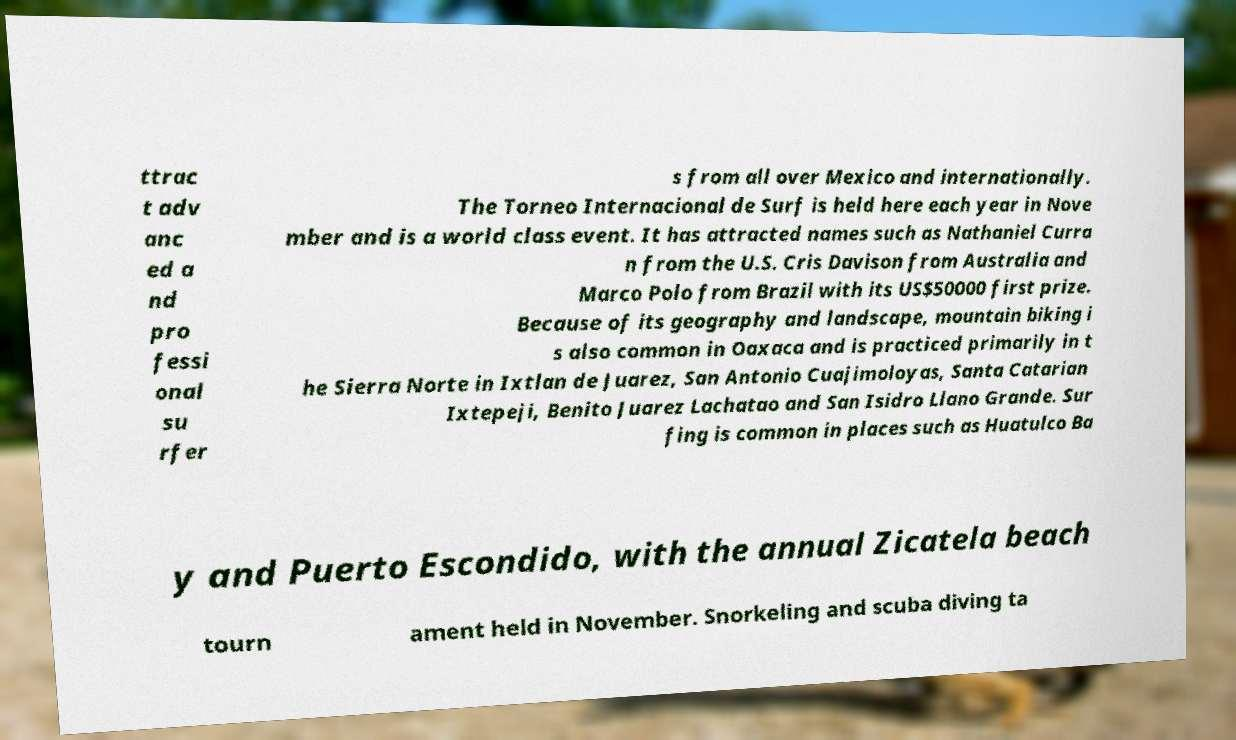Please read and relay the text visible in this image. What does it say? ttrac t adv anc ed a nd pro fessi onal su rfer s from all over Mexico and internationally. The Torneo Internacional de Surf is held here each year in Nove mber and is a world class event. It has attracted names such as Nathaniel Curra n from the U.S. Cris Davison from Australia and Marco Polo from Brazil with its US$50000 first prize. Because of its geography and landscape, mountain biking i s also common in Oaxaca and is practiced primarily in t he Sierra Norte in Ixtlan de Juarez, San Antonio Cuajimoloyas, Santa Catarian Ixtepeji, Benito Juarez Lachatao and San Isidro Llano Grande. Sur fing is common in places such as Huatulco Ba y and Puerto Escondido, with the annual Zicatela beach tourn ament held in November. Snorkeling and scuba diving ta 